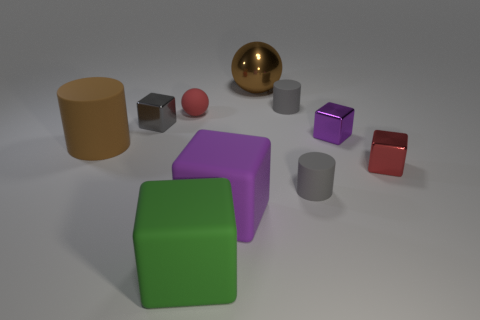There is a small metal block that is in front of the brown thing that is in front of the brown shiny sphere; is there a red metal cube that is on the left side of it?
Ensure brevity in your answer.  No. What is the shape of the small thing that is on the left side of the big sphere and to the right of the tiny gray block?
Offer a terse response. Sphere. Are there any other cylinders of the same color as the large cylinder?
Your answer should be compact. No. The shiny block in front of the cylinder that is left of the metallic ball is what color?
Offer a terse response. Red. What size is the brown cylinder in front of the large brown thing right of the metal block that is to the left of the large brown metallic ball?
Your answer should be compact. Large. Does the red block have the same material as the gray cylinder in front of the brown rubber cylinder?
Offer a very short reply. No. There is a green block that is made of the same material as the brown cylinder; what is its size?
Make the answer very short. Large. Is there a red shiny thing that has the same shape as the tiny red matte thing?
Make the answer very short. No. What number of things are big purple matte cubes that are in front of the large metallic ball or large cyan matte cubes?
Your answer should be compact. 1. There is a metal thing that is the same color as the tiny matte sphere; what size is it?
Give a very brief answer. Small. 